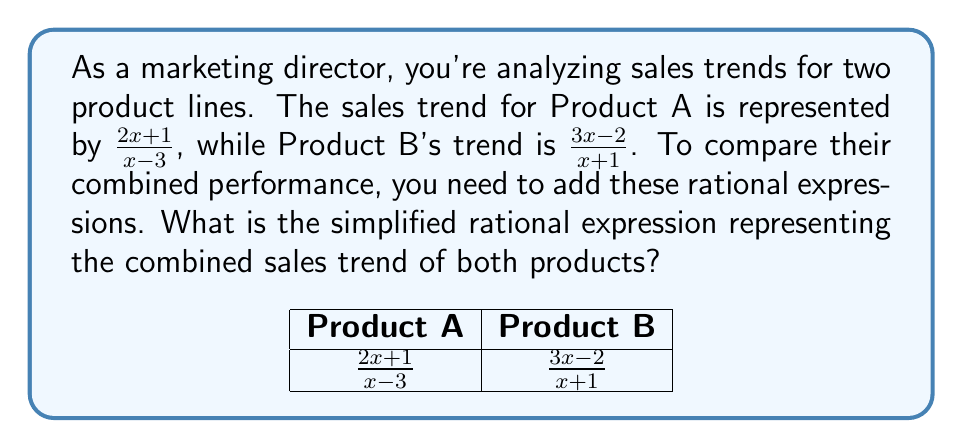Can you answer this question? Let's approach this step-by-step:

1) To add rational expressions, we need a common denominator. The common denominator will be the product of the individual denominators:
   $$(x-3)(x+1)$$

2) Multiply each numerator and denominator by the factor needed to get the common denominator:

   For Product A: $\frac{2x+1}{x-3} \cdot \frac{x+1}{x+1} = \frac{(2x+1)(x+1)}{(x-3)(x+1)}$
   
   For Product B: $\frac{3x-2}{x+1} \cdot \frac{x-3}{x-3} = \frac{(3x-2)(x-3)}{(x+1)(x-3)}$

3) Expand the numerators:

   Product A: $\frac{2x^2+2x+x+1}{(x-3)(x+1)} = \frac{2x^2+3x+1}{(x-3)(x+1)}$
   
   Product B: $\frac{3x^2-9x-2x+6}{(x-3)(x+1)} = \frac{3x^2-11x+6}{(x-3)(x+1)}$

4) Add the numerators:

   $\frac{2x^2+3x+1}{(x-3)(x+1)} + \frac{3x^2-11x+6}{(x-3)(x+1)} = \frac{(2x^2+3x+1)+(3x^2-11x+6)}{(x-3)(x+1)}$

5) Simplify the numerator:

   $\frac{5x^2-8x+7}{(x-3)(x+1)}$

This is the simplified rational expression representing the combined sales trend.
Answer: $\frac{5x^2-8x+7}{(x-3)(x+1)}$ 